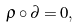Convert formula to latex. <formula><loc_0><loc_0><loc_500><loc_500>\rho \circ \partial = 0 ,</formula> 